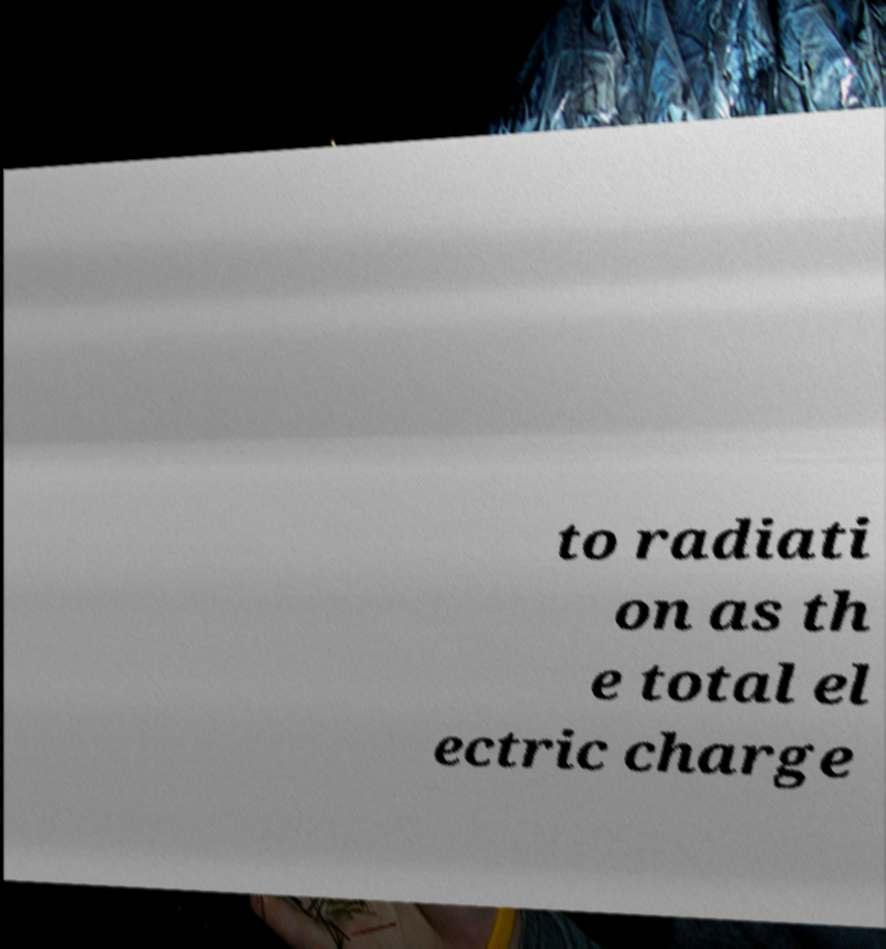Please read and relay the text visible in this image. What does it say? to radiati on as th e total el ectric charge 